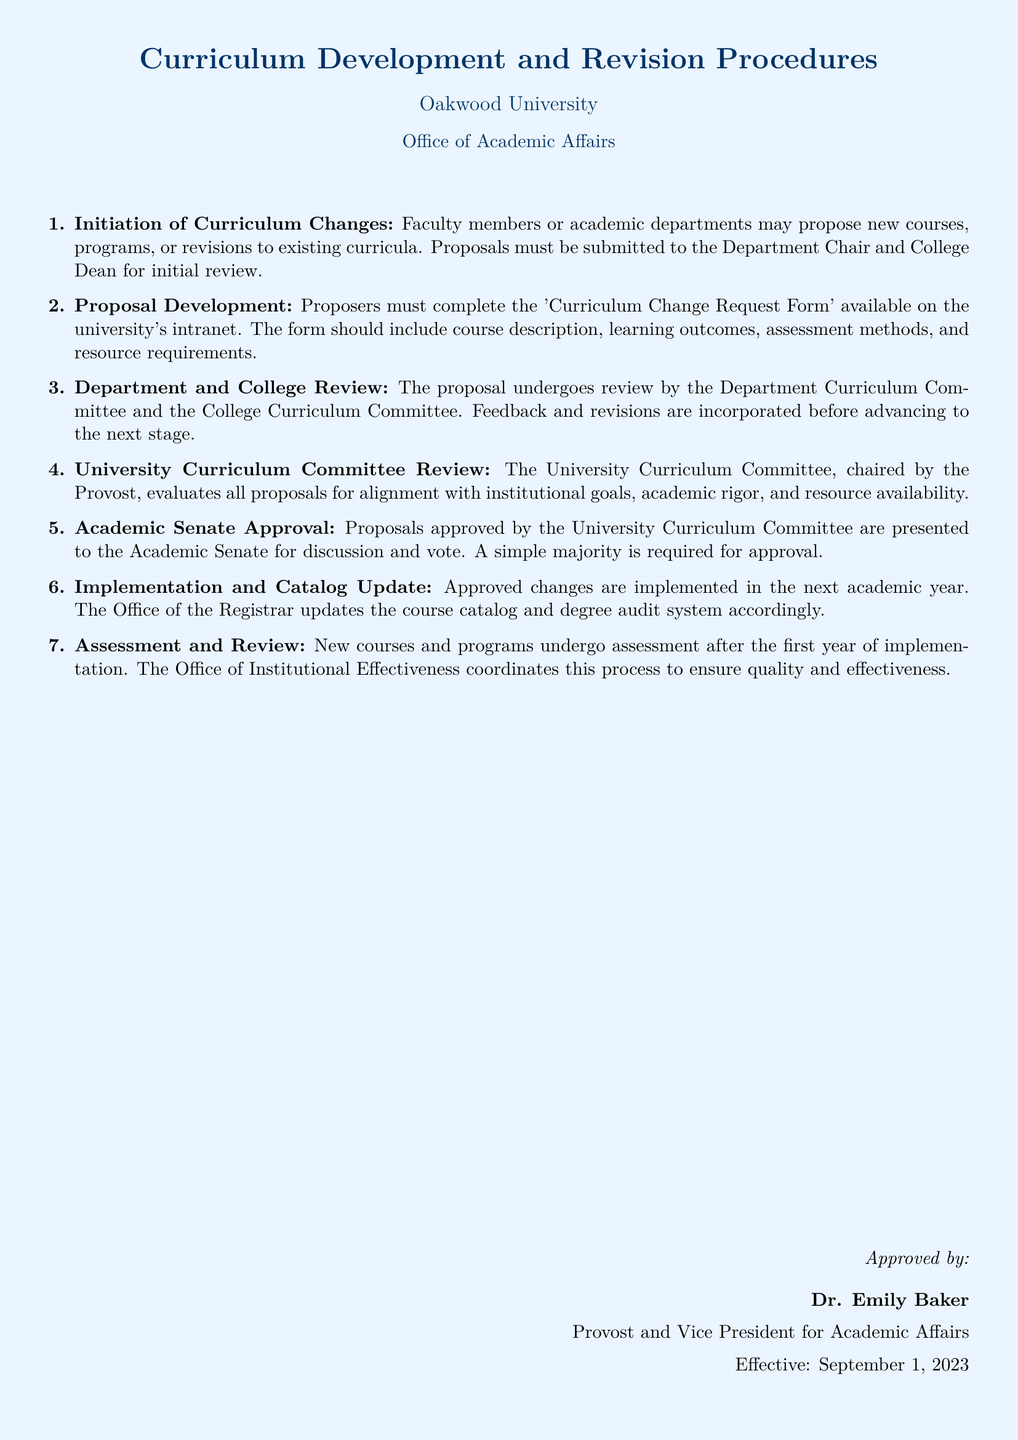What is the title of the document? The title of the document is prominently displayed at the beginning, indicating its purpose and content.
Answer: Curriculum Development and Revision Procedures Who must review the proposals before they reach the University Curriculum Committee? The initial review process involves specific committees within the department and college, which are crucial for feedback and revisions.
Answer: Department Curriculum Committee and College Curriculum Committee What form must proposers complete for curriculum changes? The document specifies a required form that outlines essential information for the proposal process.
Answer: Curriculum Change Request Form Who chairs the University Curriculum Committee? The document includes the information regarding leadership within the committee responsible for evaluating proposals.
Answer: Provost What is the required approval percentage from the Academic Senate? This detail indicates the consensus required for moving a proposal forward within the governing structure.
Answer: Simple majority When does the Office of the Registrar update the course catalog? The timing of the catalog update is outlined in relation to the approval and implementation of curriculum changes.
Answer: Next academic year Which office coordinates the assessment process of new courses and programs? This detail is mentioned to assign responsibility for assessing the effectiveness of newly implemented curricula.
Answer: Office of Institutional Effectiveness What is the effective date of the document? The document includes an effective date, which establishes when the procedures begin to apply.
Answer: September 1, 2023 